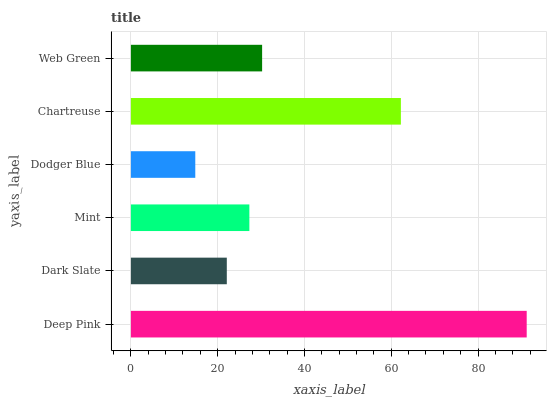Is Dodger Blue the minimum?
Answer yes or no. Yes. Is Deep Pink the maximum?
Answer yes or no. Yes. Is Dark Slate the minimum?
Answer yes or no. No. Is Dark Slate the maximum?
Answer yes or no. No. Is Deep Pink greater than Dark Slate?
Answer yes or no. Yes. Is Dark Slate less than Deep Pink?
Answer yes or no. Yes. Is Dark Slate greater than Deep Pink?
Answer yes or no. No. Is Deep Pink less than Dark Slate?
Answer yes or no. No. Is Web Green the high median?
Answer yes or no. Yes. Is Mint the low median?
Answer yes or no. Yes. Is Dark Slate the high median?
Answer yes or no. No. Is Web Green the low median?
Answer yes or no. No. 